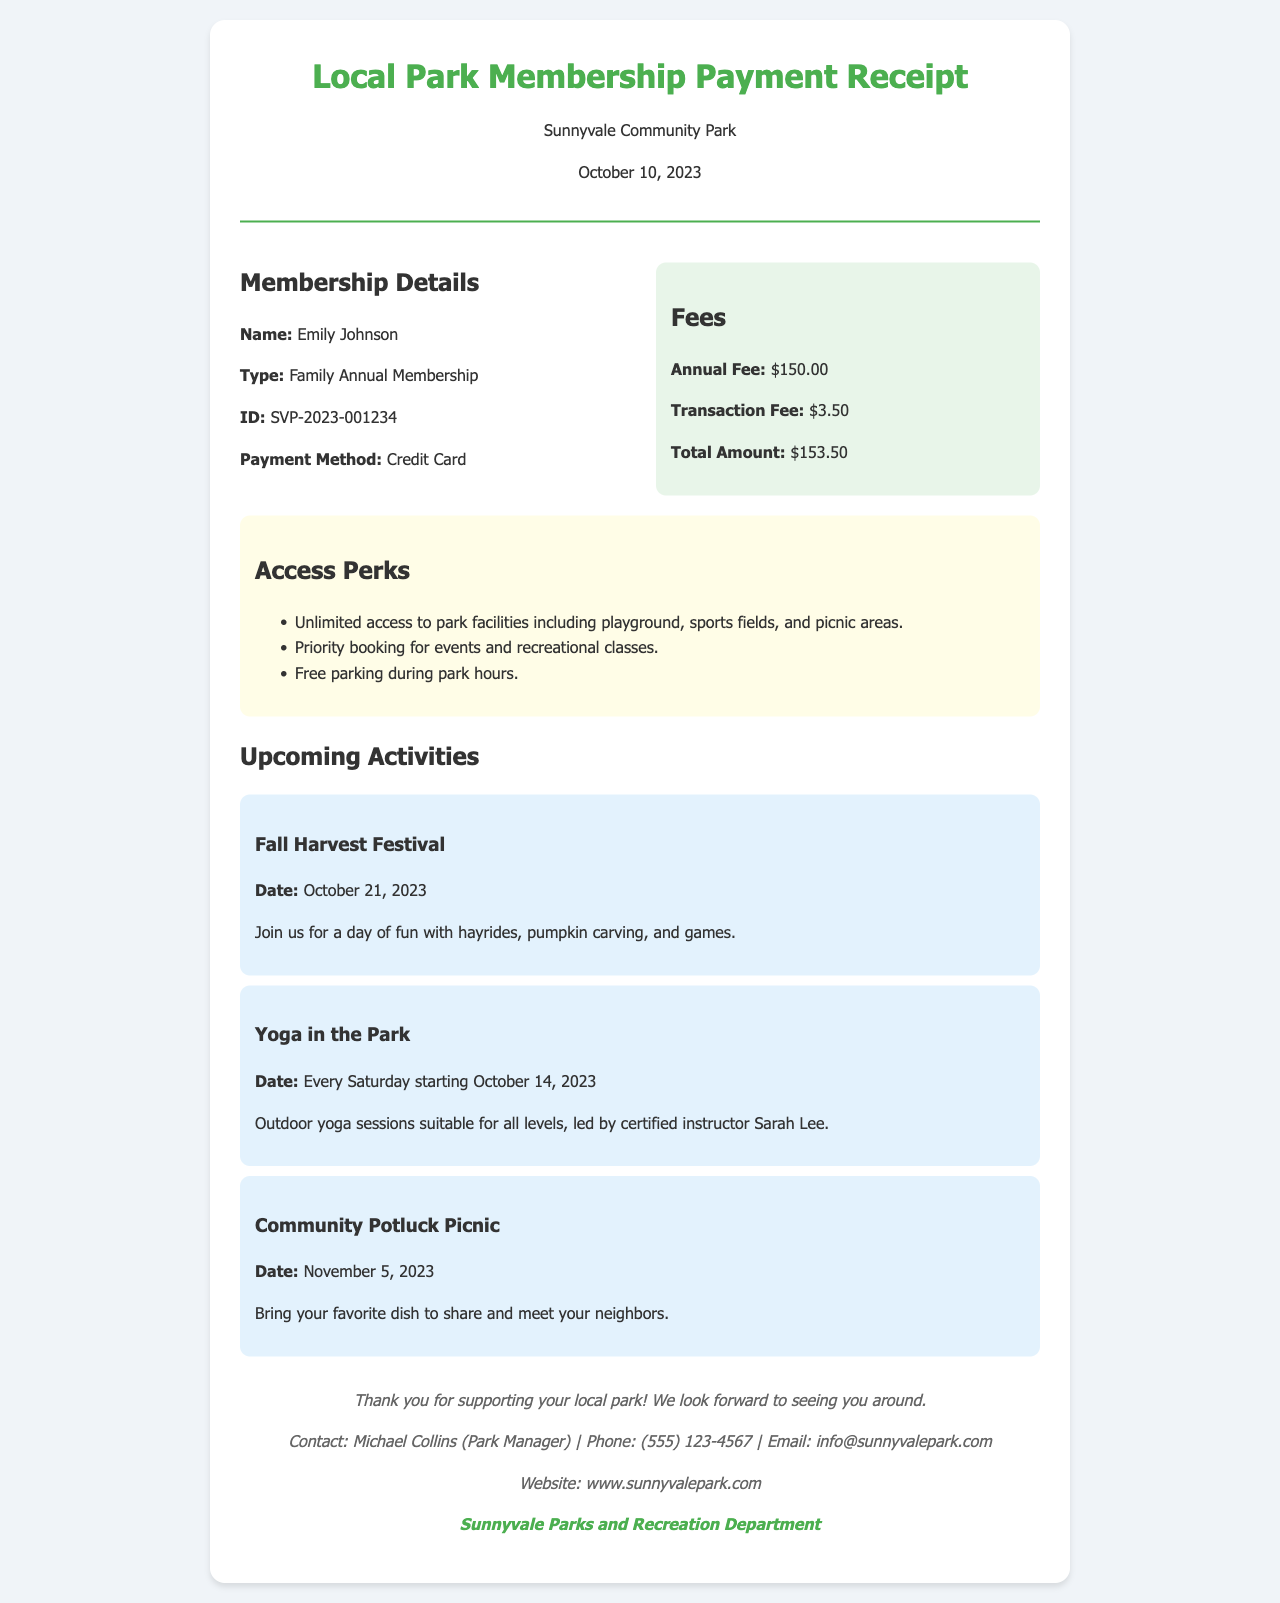What is the name of the member? The member's name is highlighted in the membership details section.
Answer: Emily Johnson What is the type of membership? The membership type is stated clearly under membership details.
Answer: Family Annual Membership What is the total amount paid? The total amount paid is calculated from the annual fee and transaction fee shown in the fees section.
Answer: $153.50 When is the Fall Harvest Festival? The date of the Fall Harvest Festival is listed under the upcoming activities section.
Answer: October 21, 2023 What payment method was used for the membership? The payment method is included in the membership details section.
Answer: Credit Card What perks come with park access? The access perks are outlined as a list in the access information section.
Answer: Unlimited access to park facilities including playground, sports fields, and picnic areas How much is the annual fee? The annual fee is specified in the fees section of the receipt.
Answer: $150.00 What is the date for Yoga in the Park? The schedule for Yoga in the Park is provided in the upcoming activities section.
Answer: Every Saturday starting October 14, 2023 Who should be contacted for more information? The contact information is provided in the footer of the document.
Answer: Michael Collins (Park Manager) 